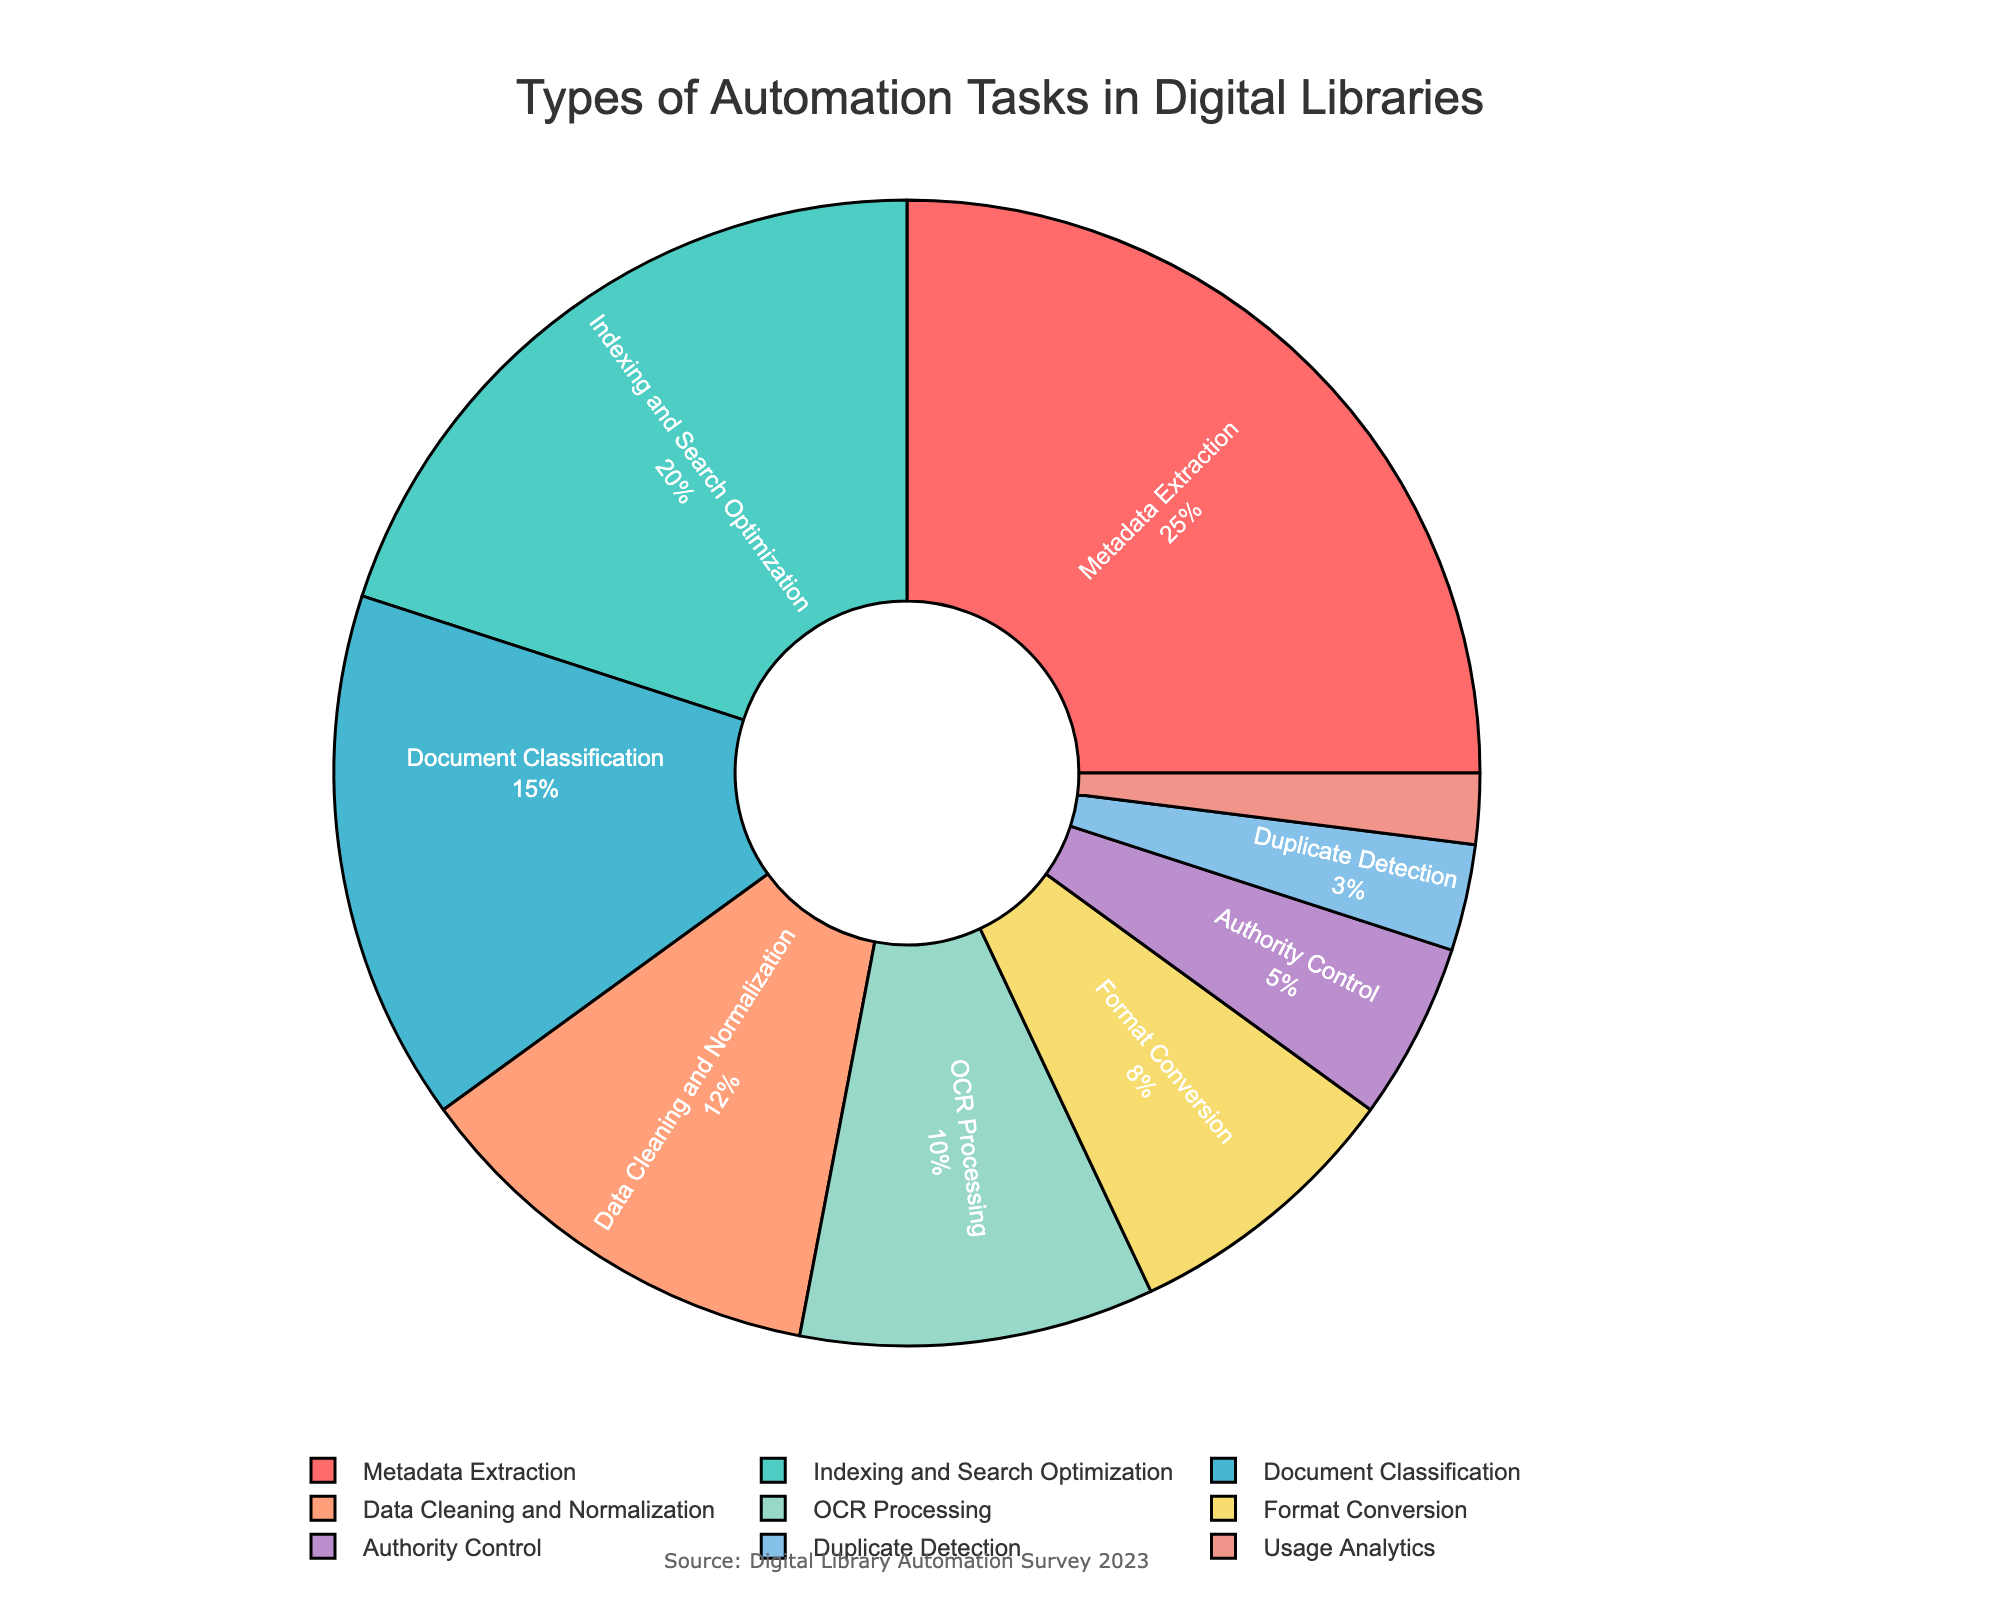What percentage of the pie chart does "Data Cleaning and Normalization" occupy? "Data Cleaning and Normalization" segment shows a percentage value directly on the pie chart. By looking at that segment, we see it occupies 12%.
Answer: 12% Which task is the second most frequently implemented after "Metadata Extraction"? The segment labeled "Metadata Extraction" has the highest percentage at 25%. The next largest segment can be identified, which is "Indexing and Search Optimization" with 20%.
Answer: Indexing and Search Optimization How many tasks have a percentage higher than 10%? By visually inspecting the pie chart, the segments with percentages higher than 10% can be identified: "Metadata Extraction" (25%), "Indexing and Search Optimization" (20%), "Document Classification" (15%), "Data Cleaning and Normalization" (12%), and "OCR Processing" (10%). This totals to 5 tasks.
Answer: 5 Compare the combined percentage of "Format Conversion" and "Authority Control" with "Document Classification". Which is larger, and by how much? "Format Conversion" is 8% and "Authority Control" is 5%. Adding them, we get 8% + 5% = 13%. "Document Classification" is 15%. Comparing 15% and 13%, "Document Classification" is larger by 2%.
Answer: Document Classification is larger by 2% What is the difference in percentage between the most frequently and the least frequently implemented tasks? "Metadata Extraction" is the most frequent with 25%, and "Usage Analytics" is the least frequent with 2%. The difference is calculated as 25% - 2% = 23%.
Answer: 23% Which color corresponds to the task "Duplicate Detection"? The segment labeled "Duplicate Detection" can be visually checked. It is associated with a specific color in the chart. Identifying the color, it is teal.
Answer: teal Rank the tasks "OCR Processing", "Format Conversion", and "Authority Control" by their implementation frequency. Looking at the pie chart, "OCR Processing" has a percentage of 10%, "Format Conversion" has 8%, and "Authority Control" has 5%. Arranging them in descending order gives: "OCR Processing" > "Format Conversion" > "Authority Control".
Answer: OCR Processing > Format Conversion > Authority Control Add the percentages of "Document Classification", "Data Cleaning and Normalization", and "Format Conversion". What is the total percentage? "Document Classification" is 15%, "Data Cleaning and Normalization" is 12%, and "Format Conversion" is 8%. Summing them up: 15% + 12% + 8% = 35%.
Answer: 35% Which task has the smallest segment and what percentage does it represent? By visually inspecting the smallest segment in the pie chart, we see it is labeled "Usage Analytics", which is also verified by the percentage indicated as 2%.
Answer: Usage Analytics, 2% 